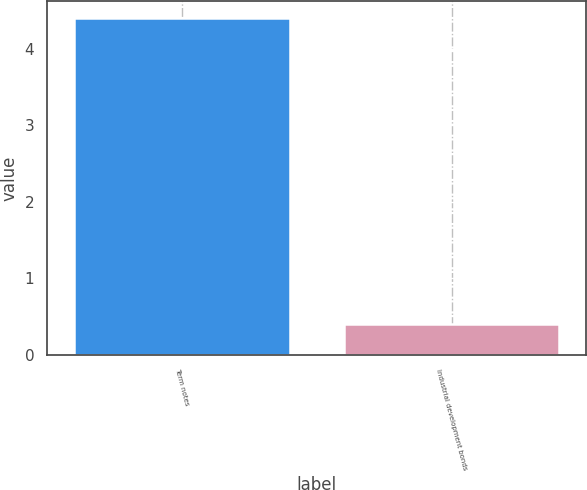Convert chart. <chart><loc_0><loc_0><loc_500><loc_500><bar_chart><fcel>Term notes<fcel>Industrial development bonds<nl><fcel>4.4<fcel>0.4<nl></chart> 